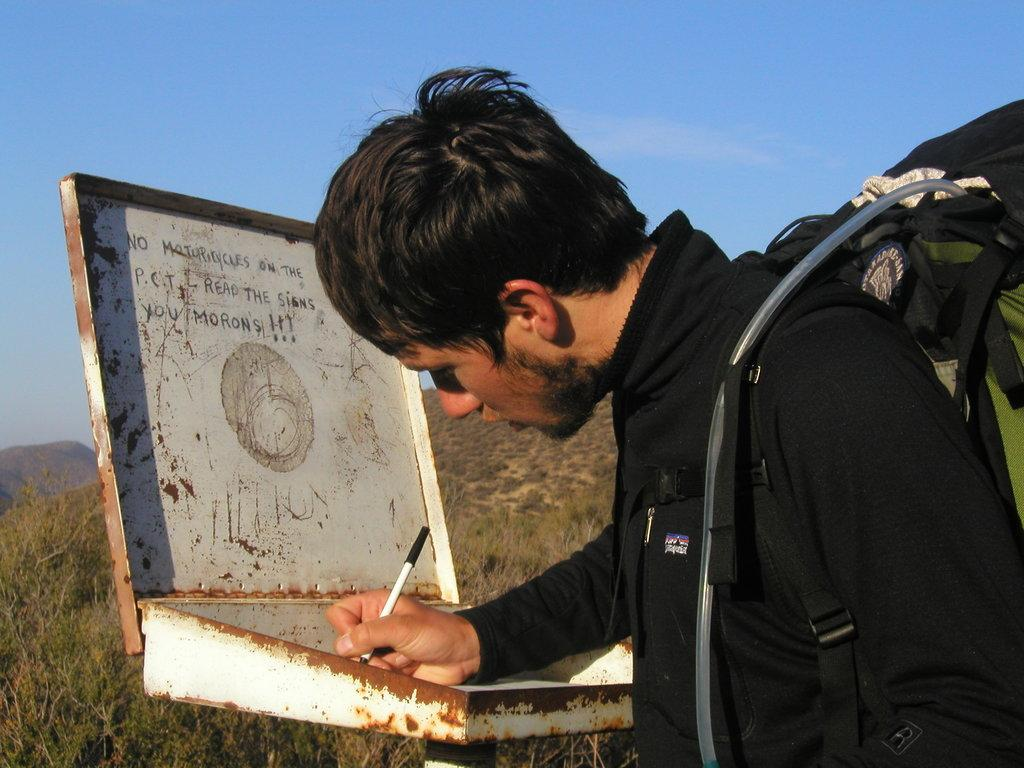What is the man in the image doing? The man is holding a pen and writing something. What can be seen in the background of the image? There are hills, trees, and the sky visible in the background of the image. What is the price of the letter the woman is holding in the image? There is no woman present in the image, and therefore no letter or price to consider. 